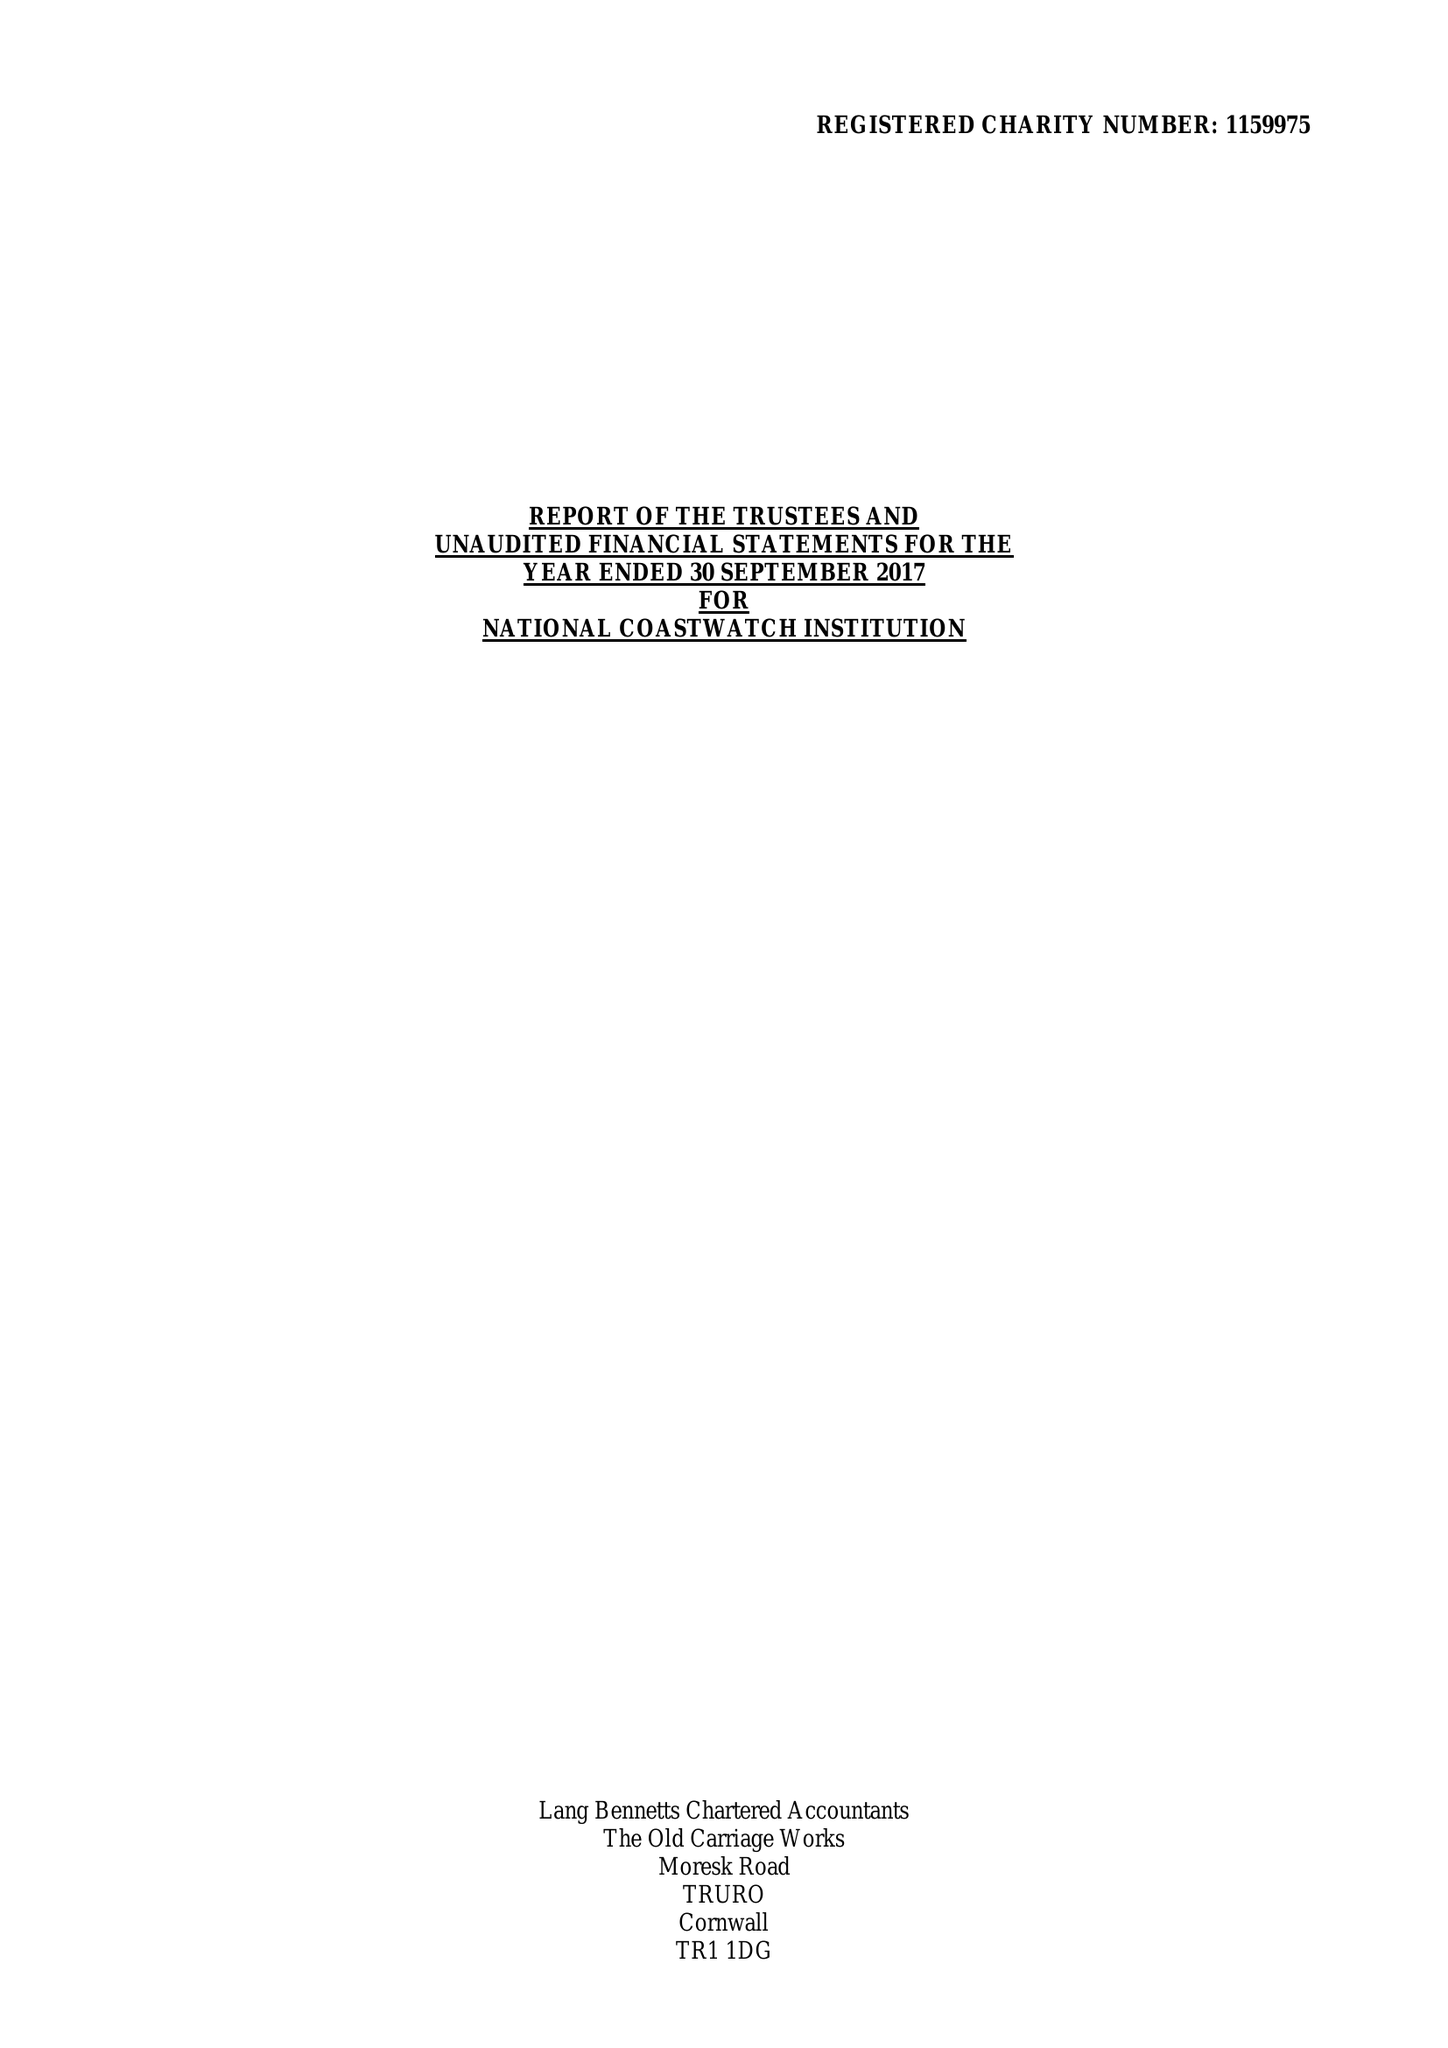What is the value for the address__postcode?
Answer the question using a single word or phrase. PL14 4AB 